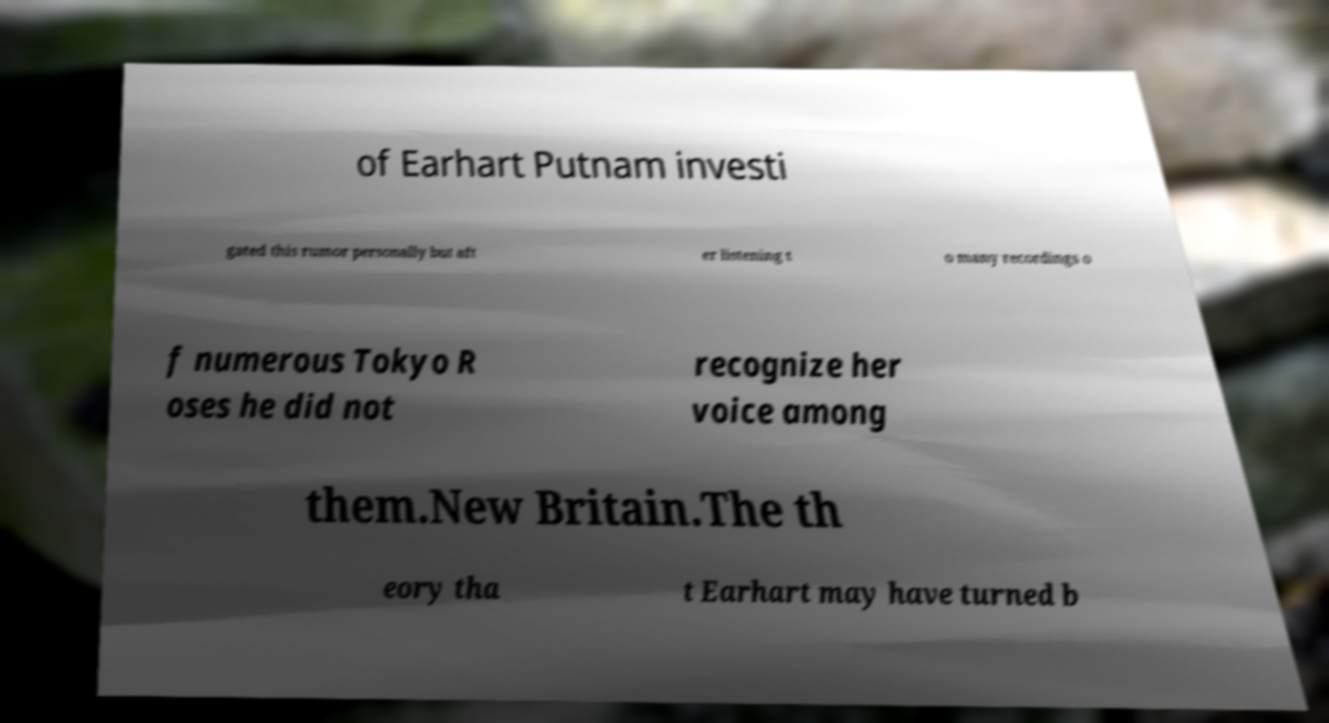There's text embedded in this image that I need extracted. Can you transcribe it verbatim? of Earhart Putnam investi gated this rumor personally but aft er listening t o many recordings o f numerous Tokyo R oses he did not recognize her voice among them.New Britain.The th eory tha t Earhart may have turned b 